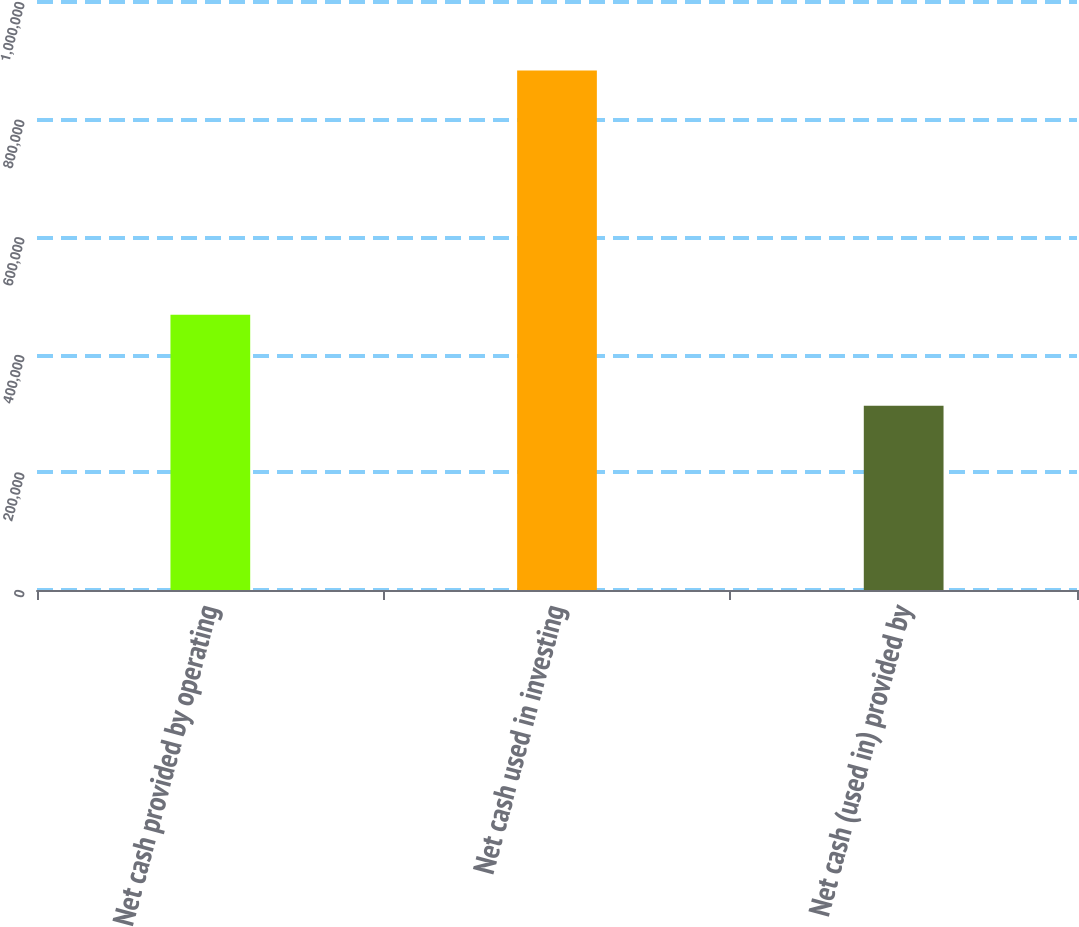Convert chart to OTSL. <chart><loc_0><loc_0><loc_500><loc_500><bar_chart><fcel>Net cash provided by operating<fcel>Net cash used in investing<fcel>Net cash (used in) provided by<nl><fcel>468229<fcel>883583<fcel>313555<nl></chart> 